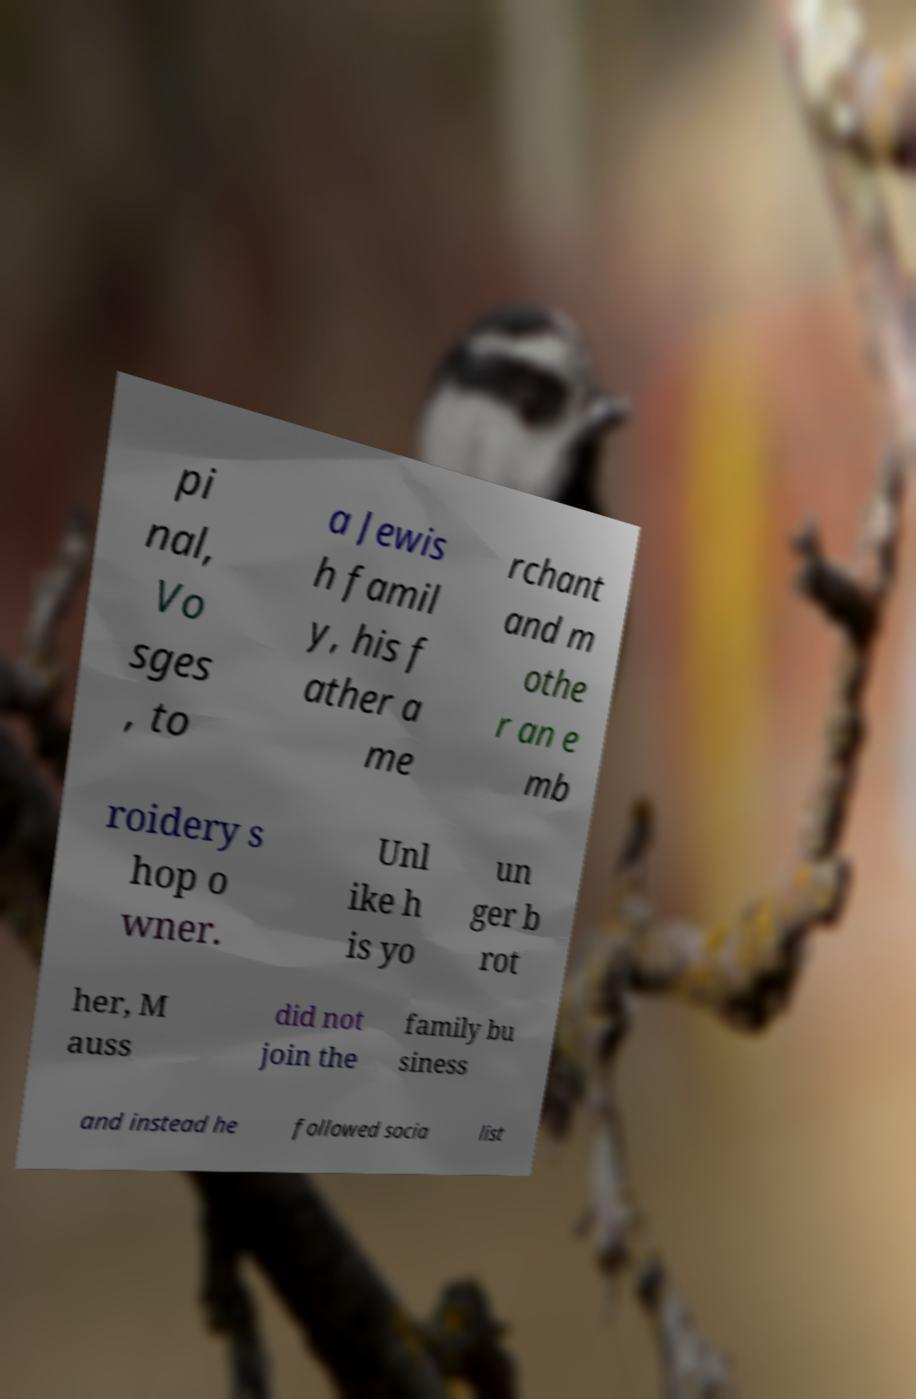What messages or text are displayed in this image? I need them in a readable, typed format. pi nal, Vo sges , to a Jewis h famil y, his f ather a me rchant and m othe r an e mb roidery s hop o wner. Unl ike h is yo un ger b rot her, M auss did not join the family bu siness and instead he followed socia list 